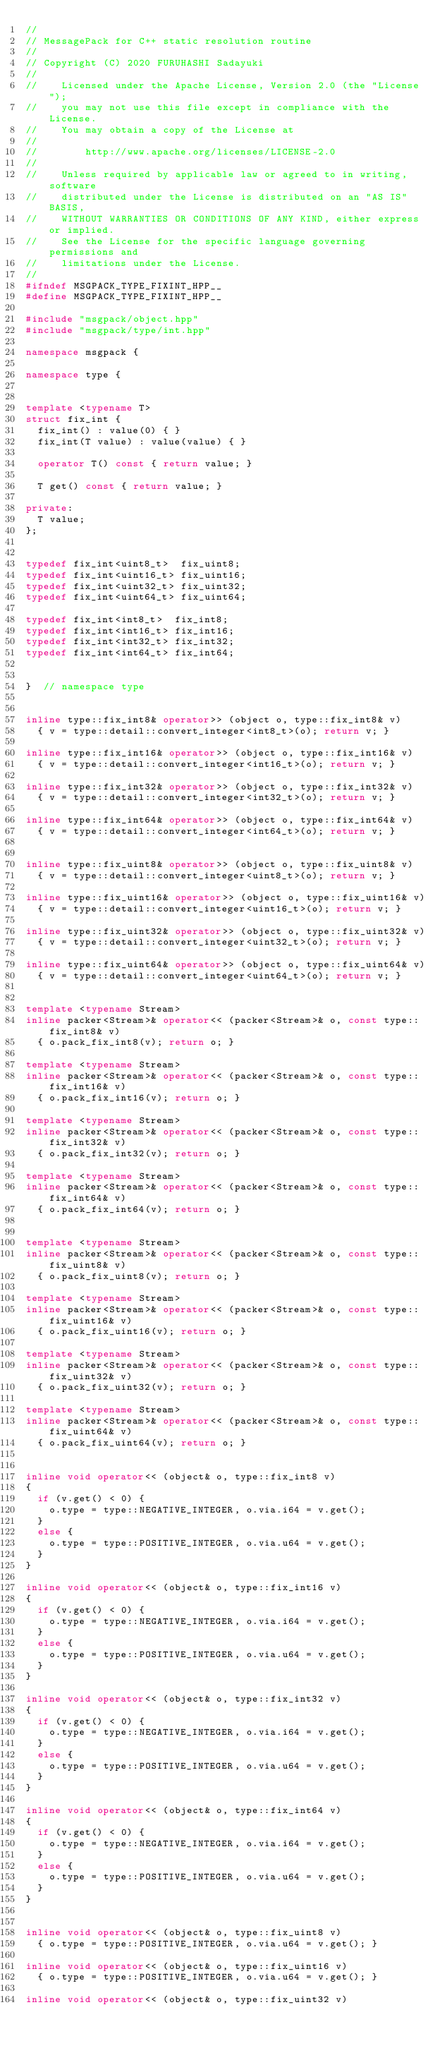<code> <loc_0><loc_0><loc_500><loc_500><_C++_>//
// MessagePack for C++ static resolution routine
//
// Copyright (C) 2020 FURUHASHI Sadayuki
//
//    Licensed under the Apache License, Version 2.0 (the "License");
//    you may not use this file except in compliance with the License.
//    You may obtain a copy of the License at
//
//        http://www.apache.org/licenses/LICENSE-2.0
//
//    Unless required by applicable law or agreed to in writing, software
//    distributed under the License is distributed on an "AS IS" BASIS,
//    WITHOUT WARRANTIES OR CONDITIONS OF ANY KIND, either express or implied.
//    See the License for the specific language governing permissions and
//    limitations under the License.
//
#ifndef MSGPACK_TYPE_FIXINT_HPP__
#define MSGPACK_TYPE_FIXINT_HPP__

#include "msgpack/object.hpp"
#include "msgpack/type/int.hpp"

namespace msgpack {

namespace type {


template <typename T>
struct fix_int {
	fix_int() : value(0) { }
	fix_int(T value) : value(value) { }

	operator T() const { return value; }

	T get() const { return value; }

private:
	T value;
};


typedef fix_int<uint8_t>  fix_uint8;
typedef fix_int<uint16_t> fix_uint16;
typedef fix_int<uint32_t> fix_uint32;
typedef fix_int<uint64_t> fix_uint64;

typedef fix_int<int8_t>  fix_int8;
typedef fix_int<int16_t> fix_int16;
typedef fix_int<int32_t> fix_int32;
typedef fix_int<int64_t> fix_int64;


}  // namespace type


inline type::fix_int8& operator>> (object o, type::fix_int8& v)
	{ v = type::detail::convert_integer<int8_t>(o); return v; }

inline type::fix_int16& operator>> (object o, type::fix_int16& v)
	{ v = type::detail::convert_integer<int16_t>(o); return v; }

inline type::fix_int32& operator>> (object o, type::fix_int32& v)
	{ v = type::detail::convert_integer<int32_t>(o); return v; }

inline type::fix_int64& operator>> (object o, type::fix_int64& v)
	{ v = type::detail::convert_integer<int64_t>(o); return v; }


inline type::fix_uint8& operator>> (object o, type::fix_uint8& v)
	{ v = type::detail::convert_integer<uint8_t>(o); return v; }

inline type::fix_uint16& operator>> (object o, type::fix_uint16& v)
	{ v = type::detail::convert_integer<uint16_t>(o); return v; }

inline type::fix_uint32& operator>> (object o, type::fix_uint32& v)
	{ v = type::detail::convert_integer<uint32_t>(o); return v; }

inline type::fix_uint64& operator>> (object o, type::fix_uint64& v)
	{ v = type::detail::convert_integer<uint64_t>(o); return v; }


template <typename Stream>
inline packer<Stream>& operator<< (packer<Stream>& o, const type::fix_int8& v)
	{ o.pack_fix_int8(v); return o; }

template <typename Stream>
inline packer<Stream>& operator<< (packer<Stream>& o, const type::fix_int16& v)
	{ o.pack_fix_int16(v); return o; }

template <typename Stream>
inline packer<Stream>& operator<< (packer<Stream>& o, const type::fix_int32& v)
	{ o.pack_fix_int32(v); return o; }

template <typename Stream>
inline packer<Stream>& operator<< (packer<Stream>& o, const type::fix_int64& v)
	{ o.pack_fix_int64(v); return o; }


template <typename Stream>
inline packer<Stream>& operator<< (packer<Stream>& o, const type::fix_uint8& v)
	{ o.pack_fix_uint8(v); return o; }

template <typename Stream>
inline packer<Stream>& operator<< (packer<Stream>& o, const type::fix_uint16& v)
	{ o.pack_fix_uint16(v); return o; }

template <typename Stream>
inline packer<Stream>& operator<< (packer<Stream>& o, const type::fix_uint32& v)
	{ o.pack_fix_uint32(v); return o; }

template <typename Stream>
inline packer<Stream>& operator<< (packer<Stream>& o, const type::fix_uint64& v)
	{ o.pack_fix_uint64(v); return o; }


inline void operator<< (object& o, type::fix_int8 v)
{ 
	if (v.get() < 0) {
		o.type = type::NEGATIVE_INTEGER, o.via.i64 = v.get();
	}
	else {
		o.type = type::POSITIVE_INTEGER, o.via.u64 = v.get();
	}
}

inline void operator<< (object& o, type::fix_int16 v)
{
	if (v.get() < 0) {
		o.type = type::NEGATIVE_INTEGER, o.via.i64 = v.get();
	}
	else {
		o.type = type::POSITIVE_INTEGER, o.via.u64 = v.get();
	}
}

inline void operator<< (object& o, type::fix_int32 v)
{
	if (v.get() < 0) {
		o.type = type::NEGATIVE_INTEGER, o.via.i64 = v.get();
	}
	else {
		o.type = type::POSITIVE_INTEGER, o.via.u64 = v.get();
	}
}

inline void operator<< (object& o, type::fix_int64 v)
{
	if (v.get() < 0) {
		o.type = type::NEGATIVE_INTEGER, o.via.i64 = v.get();
	}
	else {
		o.type = type::POSITIVE_INTEGER, o.via.u64 = v.get();
	}
}


inline void operator<< (object& o, type::fix_uint8 v)
	{ o.type = type::POSITIVE_INTEGER, o.via.u64 = v.get(); }

inline void operator<< (object& o, type::fix_uint16 v)
	{ o.type = type::POSITIVE_INTEGER, o.via.u64 = v.get(); }

inline void operator<< (object& o, type::fix_uint32 v)</code> 